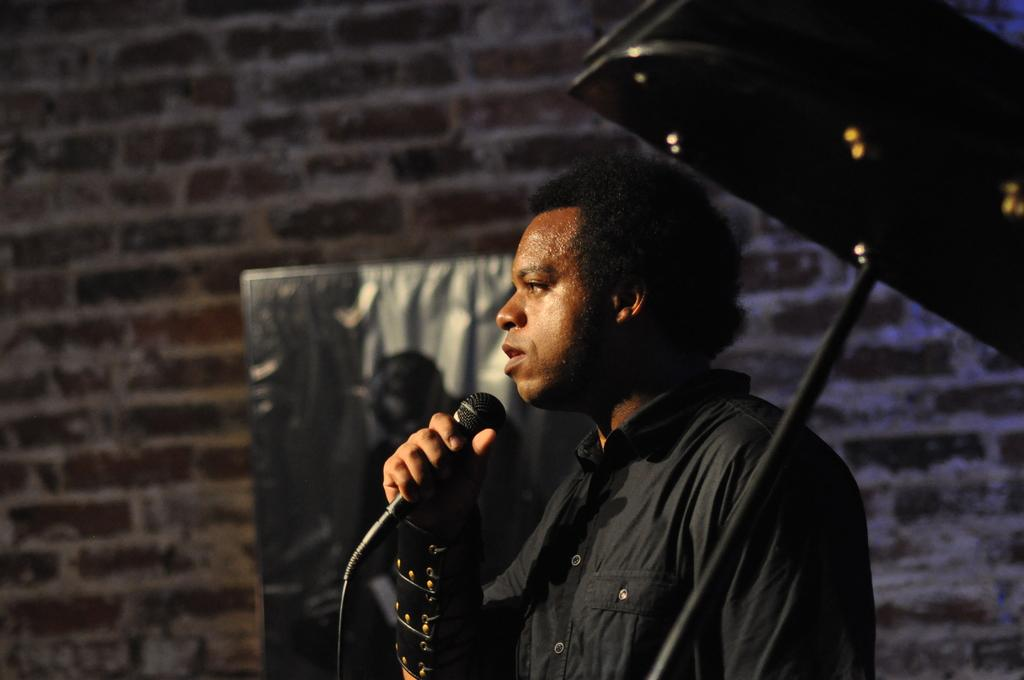What is the man in the image holding? The man is holding a microphone. What is the color and pattern of the object in the image? The object is red and black. What can be seen in the background of the image? There is a banner visible in the background, and a brick wall. What type of drug is the man offering to the audience in the image? There is no drug present in the image, nor is the man offering anything to an audience. 